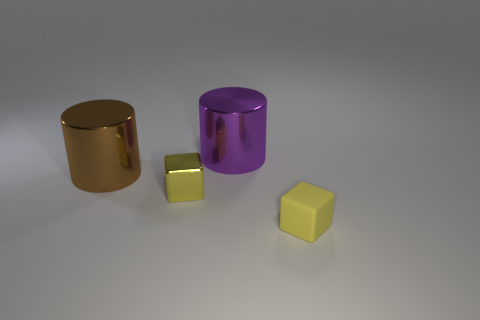What is the color of the metal object that is both on the left side of the purple cylinder and on the right side of the large brown shiny thing? The color of the metal object, which is positioned to the left of the purple cylinder and to the right of the large brown object with a shiny surface, is indeed yellow. This small cube reflects the light beautifully, showcasing its vibrant yellow hue. 